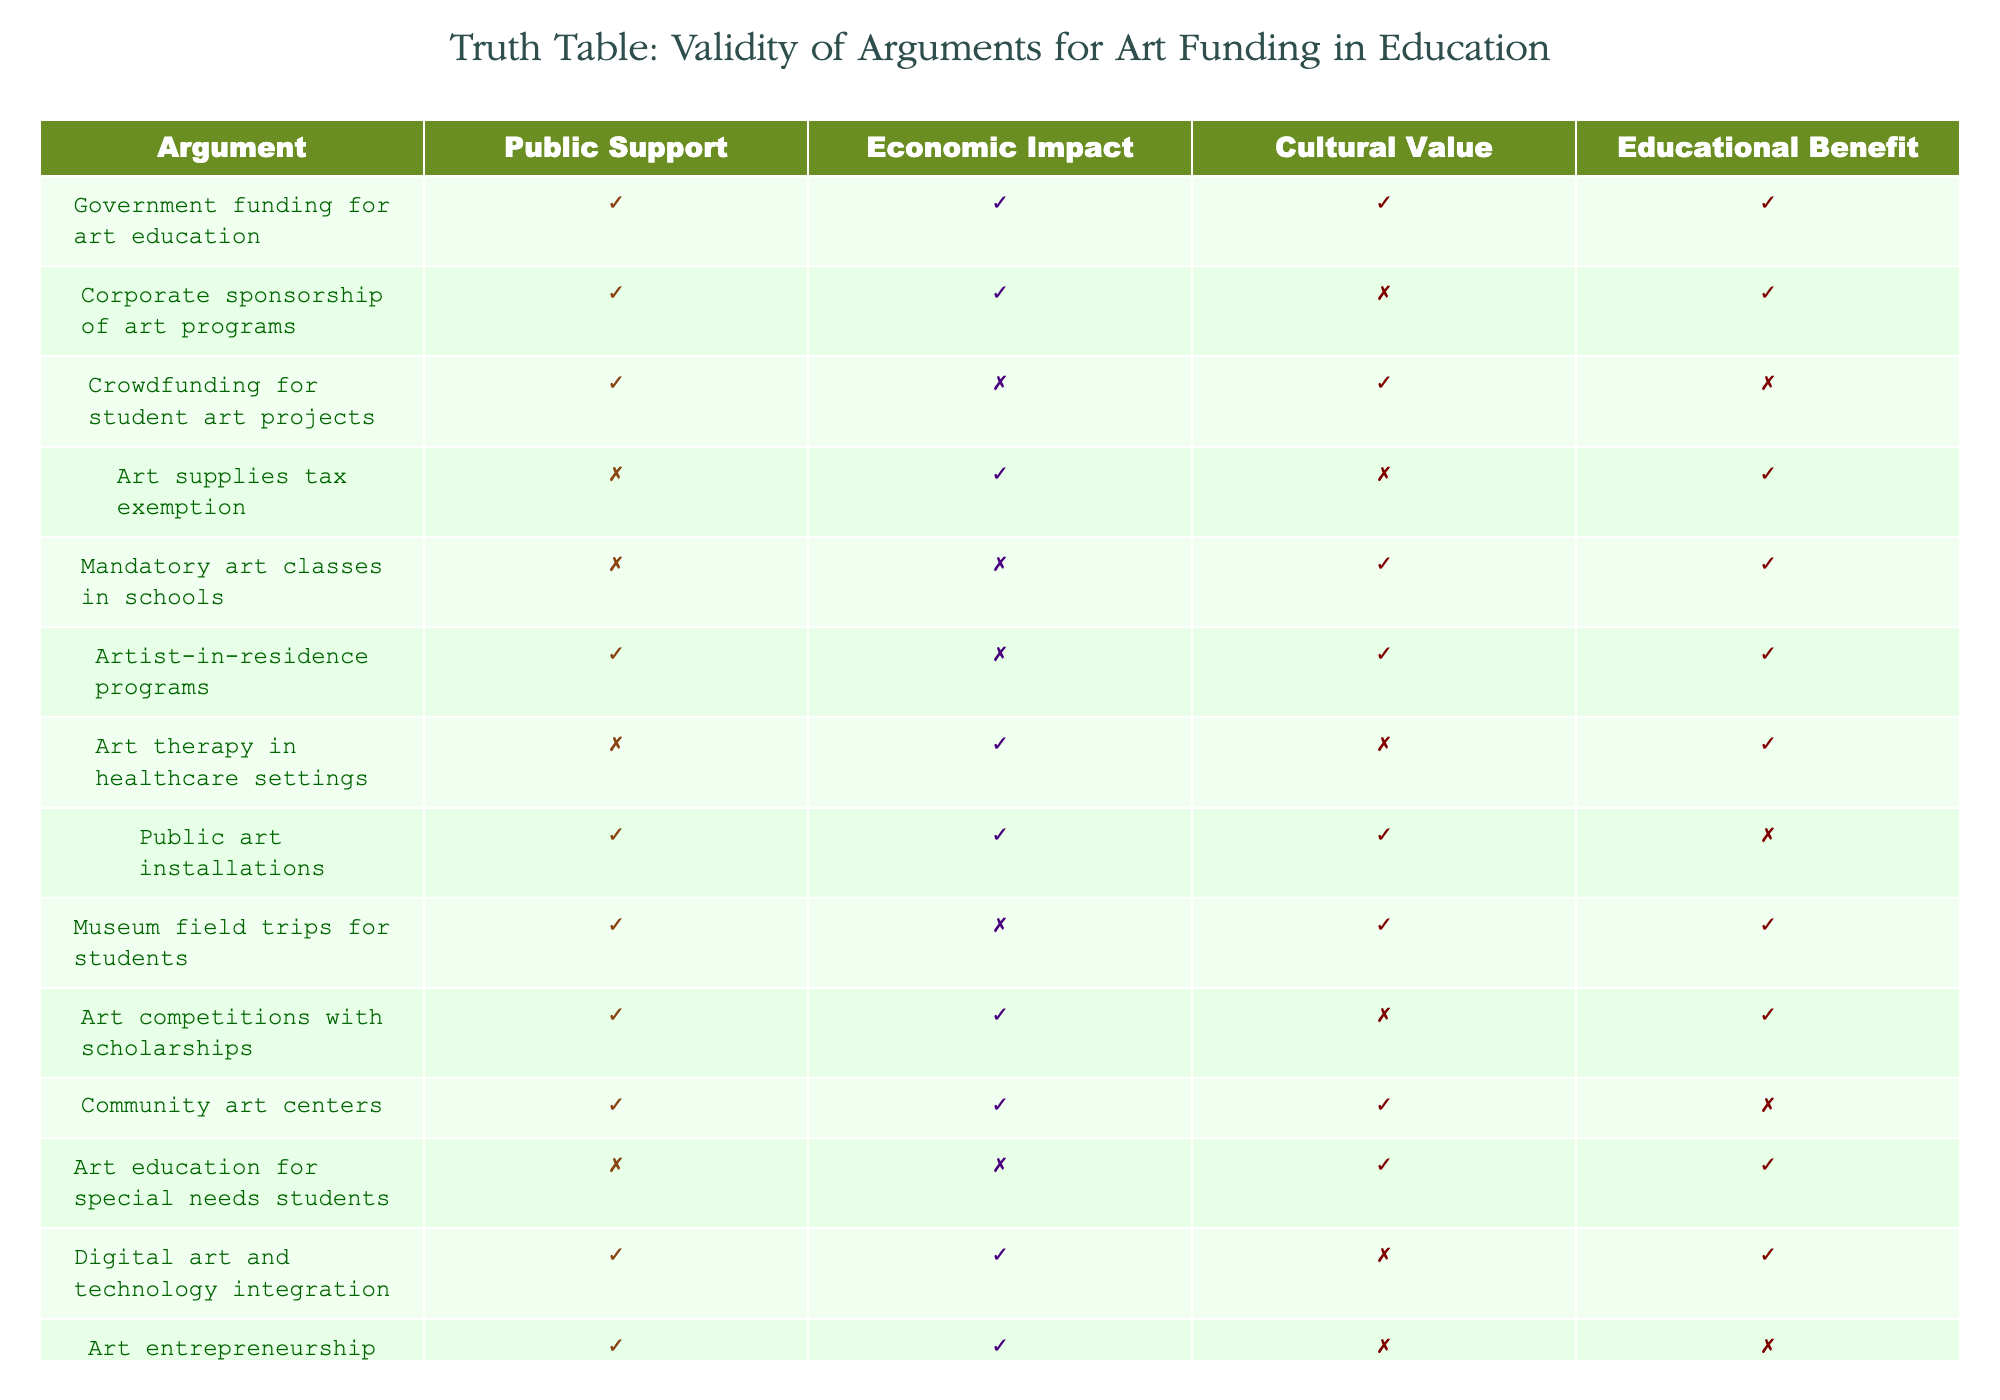What arguments show public support but lack cultural value? By analyzing the table, we can identify arguments with "TRUE" under the Public Support column and "FALSE" under the Cultural Value column. The arguments that fit this criteria are "Corporate sponsorship of art programs," "Art therapy in healthcare settings," and "Community art centers."
Answer: Corporate sponsorship of art programs, Art therapy in healthcare settings, Community art centers How many arguments have both economic impact and educational benefit? To find the number of arguments with both "TRUE" under Economic Impact and Educational Benefit, we look through the table for matches. The arguments that satisfy this condition are "Government funding for art education," "Corporate sponsorship of art programs," "Art competitions with scholarships," and "Digital art and technology integration." There are 4 such arguments.
Answer: 4 Does mandatory art classes in schools provide any economic impact? We can directly check the table for the row corresponding to "Mandatory art classes in schools." Here, the Economic Impact column shows "FALSE," indicating there is no economic impact.
Answer: No Which argument combines cultural value and educational benefit but does not have public support? In the table, we search for arguments with "TRUE" under Cultural Value and Educational Benefit while having "FALSE" under Public Support. The only argument that matches this criteria is "Art education for special needs students."
Answer: Art education for special needs students How many arguments lack public support? To answer this, we count the rows where the Public Support column is "FALSE." The arguments that fall into this category are "Art supplies tax exemption," "Mandatory art classes in schools," "Art therapy in healthcare settings," and "Art education for special needs students." Therefore, there are 4 arguments lacking public support.
Answer: 4 Which arguments are both economically impactful and lack educational benefits? We look for rows where Economic Impact is "TRUE" and Educational Benefit is "FALSE." The arguments that meet these criteria are "Art supplies tax exemption," "Artist-in-residence programs," and "Art entrepreneurship programs."
Answer: Art supplies tax exemption, Artist-in-residence programs, Art entrepreneurship programs Are there more arguments for educational benefits or against it? To determine this, we count the number of "TRUE" and "FALSE" values in the Educational Benefit column. There are 8 arguments classified as "TRUE" and 6 as "FALSE." Thus, there are more arguments for educational benefits.
Answer: For What argument has public support, economic impact, and cultural value but lacks educational benefit? Examining the table for an argument with "TRUE" in Public Support, Economic Impact, and Cultural Value and "FALSE" in Educational Benefit, we find that the only argument fitting these criteria is "Public art installations."
Answer: Public art installations 